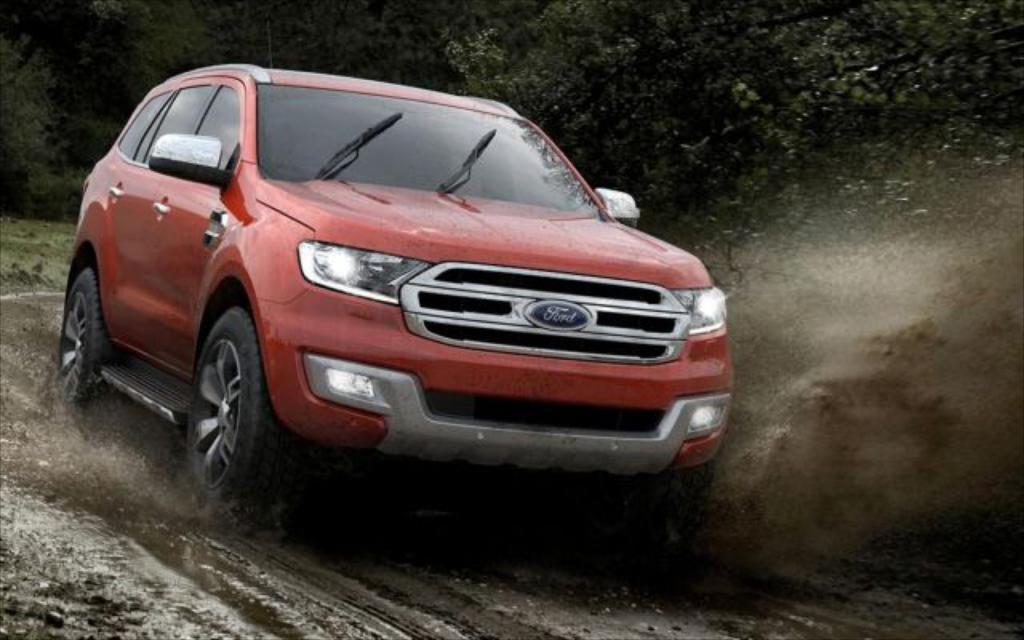Could you give a brief overview of what you see in this image? In the picture I can see a car on the road. I can see the mud and water on the road. In the background, I can see the trees. 